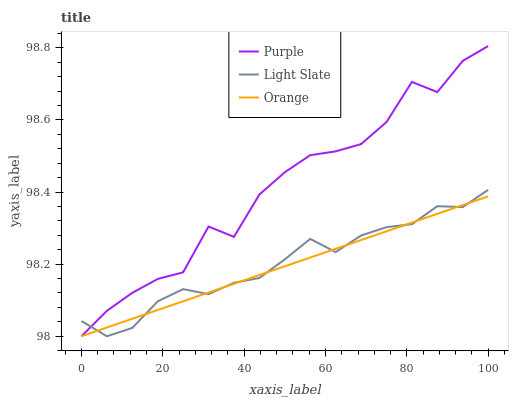Does Light Slate have the minimum area under the curve?
Answer yes or no. No. Does Light Slate have the maximum area under the curve?
Answer yes or no. No. Is Light Slate the smoothest?
Answer yes or no. No. Is Light Slate the roughest?
Answer yes or no. No. Does Light Slate have the highest value?
Answer yes or no. No. 